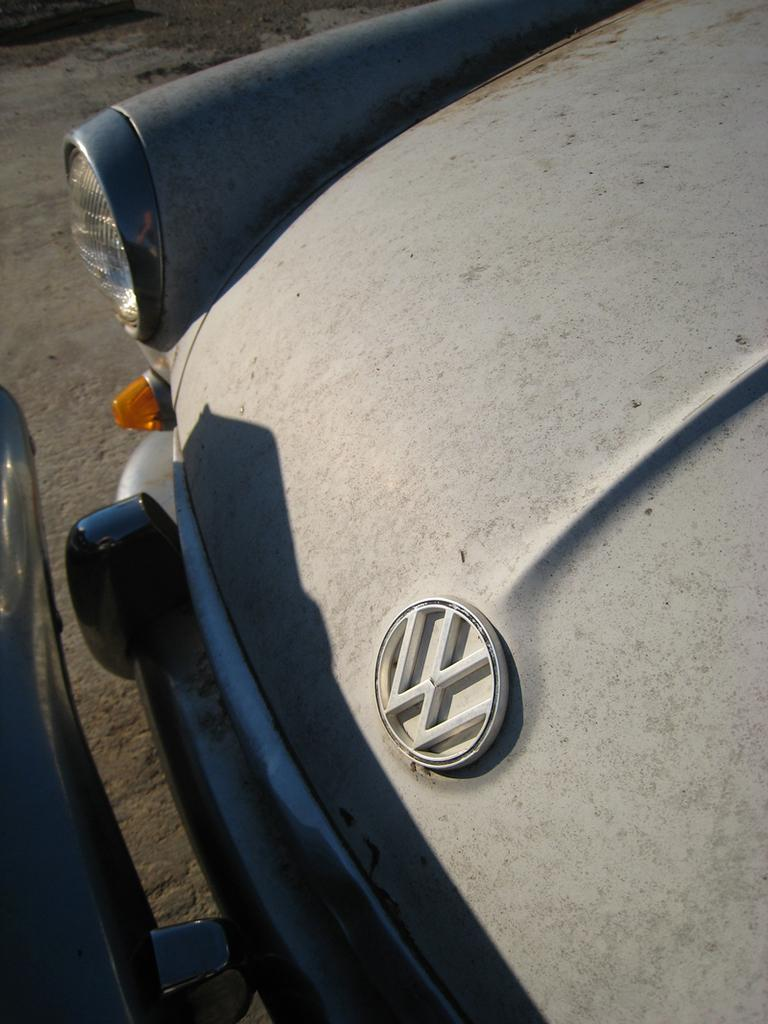What type of vehicle is the main subject of the image? There is a vintage car in the image. Is there another car in the image? Yes, there is another car in front of the vintage car in the image. Where are the cars located in the image? Both cars are on the road. What type of prison can be seen in the image? There is no prison present in the image; it features two cars on the road. How many units are visible in the image? There is no reference to units in the image, as it only features two cars on the road. 